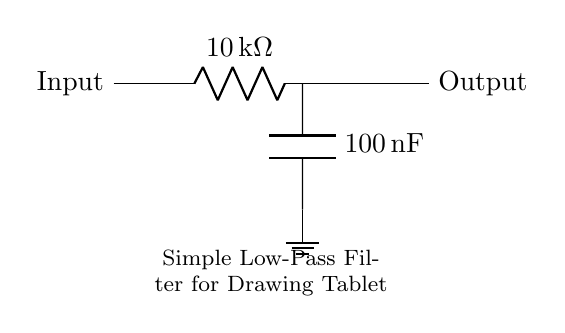What type of filter is this circuit? The circuit is labeled as a "Simple Low-Pass Filter," which indicates its function of allowing low-frequency signals to pass while attenuating high-frequency signals.
Answer: Low-Pass Filter What is the value of the resistor in this circuit? The resistor is labeled with a value of 10 kilo-ohms, which is the resistance it offers to the current flow.
Answer: 10 kilo-ohm What is the value of the capacitor in this circuit? The capacitor is labeled with a value of 100 nano-farads, which indicates its capacitance.
Answer: 100 nano-farad What does the ground symbol represent in this circuit? The ground symbol indicates a common reference point for voltage in the circuit, typically representing zero volts or earth potential.
Answer: Common reference point Why does this circuit use a low-pass filter for a drawing tablet? A low-pass filter is used to smooth out the rapid variations in hand movements on the tablet, allowing for cleaner, more stable signals that reflect the intended strokes without noise.
Answer: To smooth out hand movements What connects the components in this circuit? The components are connected by short lines, which represent electrical wires providing the pathways for the current to flow between them.
Answer: Wires How does the capacitor affect the output signal? The capacitor helps to block high-frequency signals while allowing low-frequency signals to pass, effectively smoothing the output signal of the drawing tablet.
Answer: It smooths the output signal 